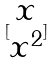<formula> <loc_0><loc_0><loc_500><loc_500>[ \begin{matrix} x \\ x ^ { 2 } \end{matrix} ]</formula> 